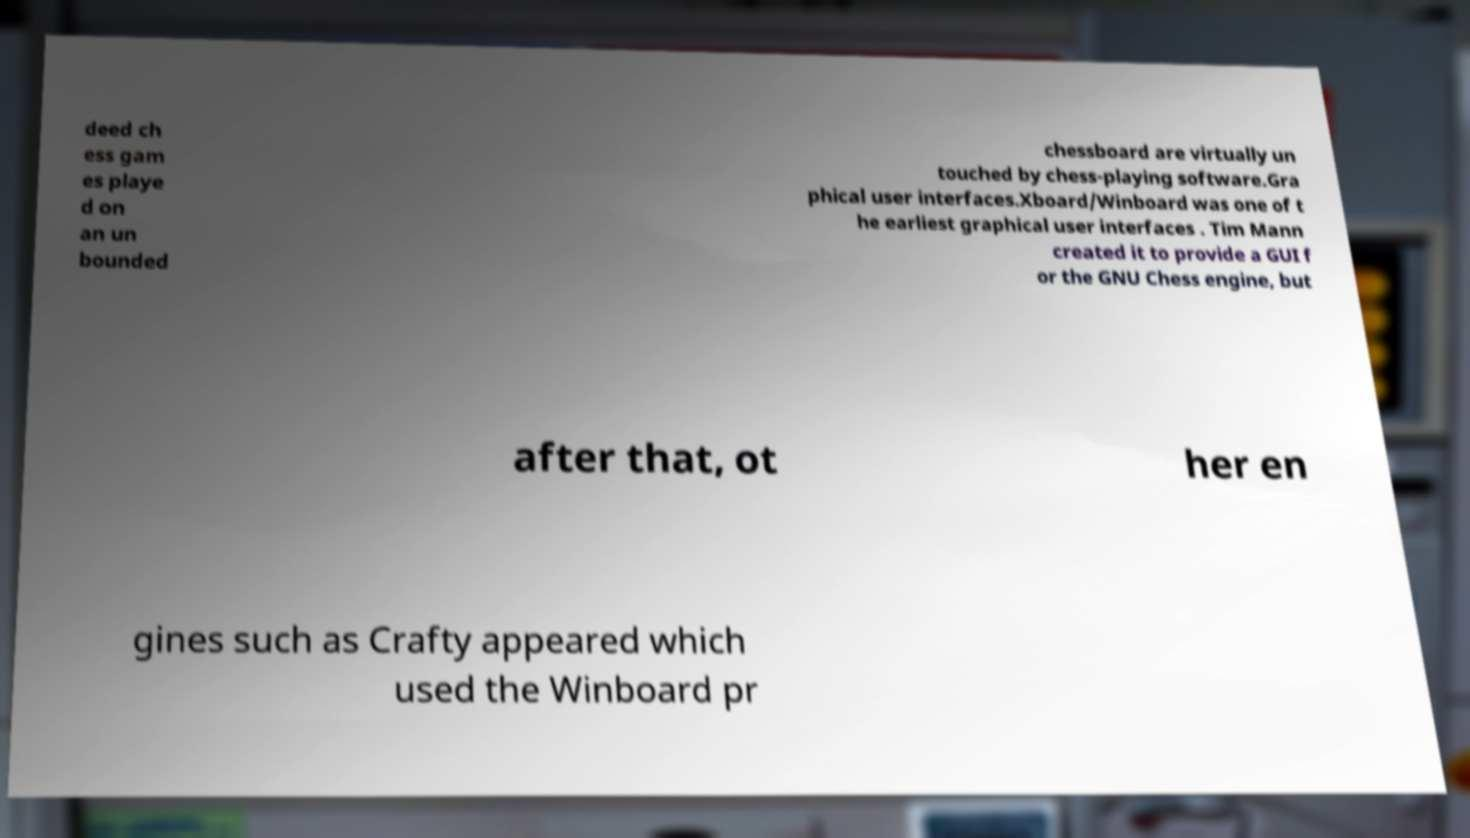Could you assist in decoding the text presented in this image and type it out clearly? deed ch ess gam es playe d on an un bounded chessboard are virtually un touched by chess-playing software.Gra phical user interfaces.Xboard/Winboard was one of t he earliest graphical user interfaces . Tim Mann created it to provide a GUI f or the GNU Chess engine, but after that, ot her en gines such as Crafty appeared which used the Winboard pr 